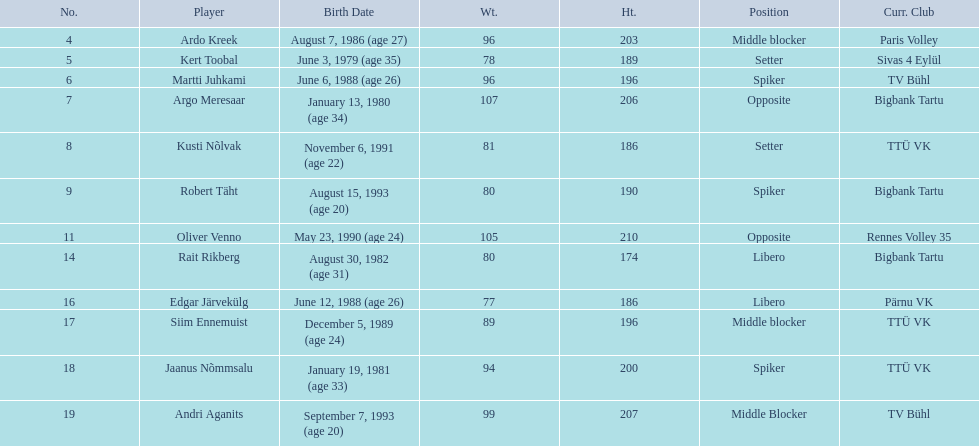Who are all of the players? Ardo Kreek, Kert Toobal, Martti Juhkami, Argo Meresaar, Kusti Nõlvak, Robert Täht, Oliver Venno, Rait Rikberg, Edgar Järvekülg, Siim Ennemuist, Jaanus Nõmmsalu, Andri Aganits. How tall are they? 203, 189, 196, 206, 186, 190, 210, 174, 186, 196, 200, 207. And which player is tallest? Oliver Venno. 